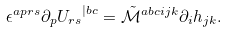<formula> <loc_0><loc_0><loc_500><loc_500>\epsilon ^ { a p r s } \partial _ { p } { U _ { r s } } ^ { | b c } = \tilde { \mathcal { M } } ^ { a b c i j k } \partial _ { i } h _ { j k } .</formula> 